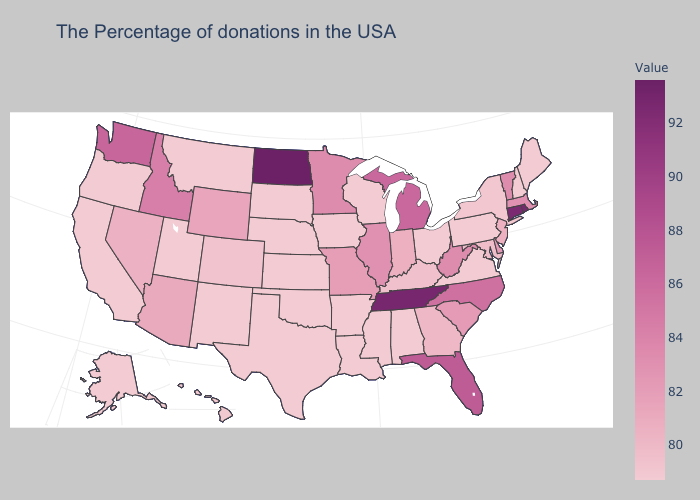Does the map have missing data?
Answer briefly. No. Does Washington have the highest value in the West?
Keep it brief. Yes. Is the legend a continuous bar?
Quick response, please. Yes. Among the states that border Michigan , which have the lowest value?
Answer briefly. Ohio, Wisconsin. Does Rhode Island have the highest value in the Northeast?
Be succinct. Yes. 